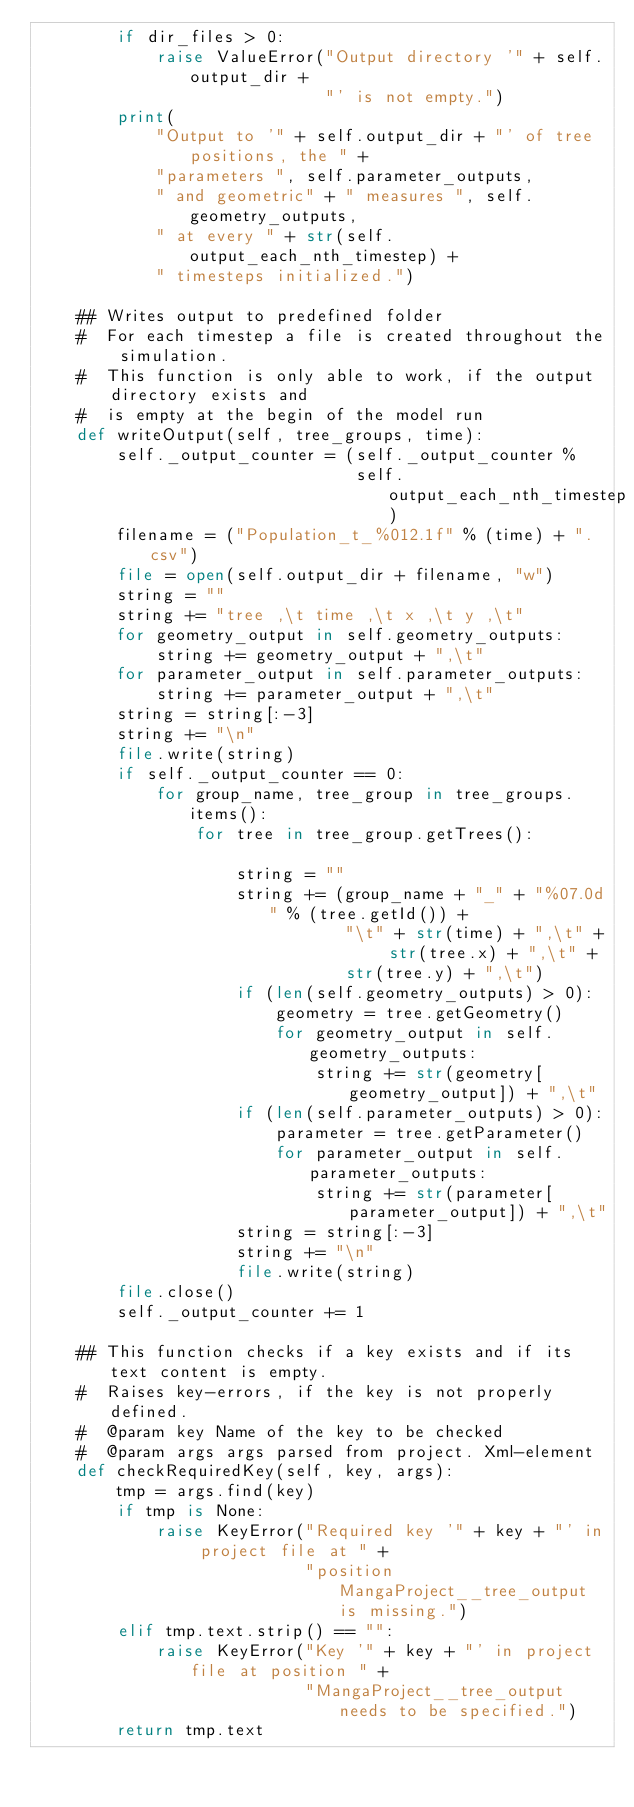<code> <loc_0><loc_0><loc_500><loc_500><_Python_>        if dir_files > 0:
            raise ValueError("Output directory '" + self.output_dir +
                             "' is not empty.")
        print(
            "Output to '" + self.output_dir + "' of tree positions, the " +
            "parameters ", self.parameter_outputs,
            " and geometric" + " measures ", self.geometry_outputs,
            " at every " + str(self.output_each_nth_timestep) +
            " timesteps initialized.")

    ## Writes output to predefined folder
    #  For each timestep a file is created throughout the simulation.
    #  This function is only able to work, if the output directory exists and
    #  is empty at the begin of the model run
    def writeOutput(self, tree_groups, time):
        self._output_counter = (self._output_counter %
                                self.output_each_nth_timestep)
        filename = ("Population_t_%012.1f" % (time) + ".csv")
        file = open(self.output_dir + filename, "w")
        string = ""
        string += "tree ,\t time ,\t x ,\t y ,\t"
        for geometry_output in self.geometry_outputs:
            string += geometry_output + ",\t"
        for parameter_output in self.parameter_outputs:
            string += parameter_output + ",\t"
        string = string[:-3]
        string += "\n"
        file.write(string)
        if self._output_counter == 0:
            for group_name, tree_group in tree_groups.items():
                for tree in tree_group.getTrees():

                    string = ""
                    string += (group_name + "_" + "%07.0d" % (tree.getId()) +
                               "\t" + str(time) + ",\t" + str(tree.x) + ",\t" +
                               str(tree.y) + ",\t")
                    if (len(self.geometry_outputs) > 0):
                        geometry = tree.getGeometry()
                        for geometry_output in self.geometry_outputs:
                            string += str(geometry[geometry_output]) + ",\t"
                    if (len(self.parameter_outputs) > 0):
                        parameter = tree.getParameter()
                        for parameter_output in self.parameter_outputs:
                            string += str(parameter[parameter_output]) + ",\t"
                    string = string[:-3]
                    string += "\n"
                    file.write(string)
        file.close()
        self._output_counter += 1

    ## This function checks if a key exists and if its text content is empty.
    #  Raises key-errors, if the key is not properly defined.
    #  @param key Name of the key to be checked
    #  @param args args parsed from project. Xml-element
    def checkRequiredKey(self, key, args):
        tmp = args.find(key)
        if tmp is None:
            raise KeyError("Required key '" + key + "' in project file at " +
                           "position MangaProject__tree_output is missing.")
        elif tmp.text.strip() == "":
            raise KeyError("Key '" + key + "' in project file at position " +
                           "MangaProject__tree_output needs to be specified.")
        return tmp.text
</code> 